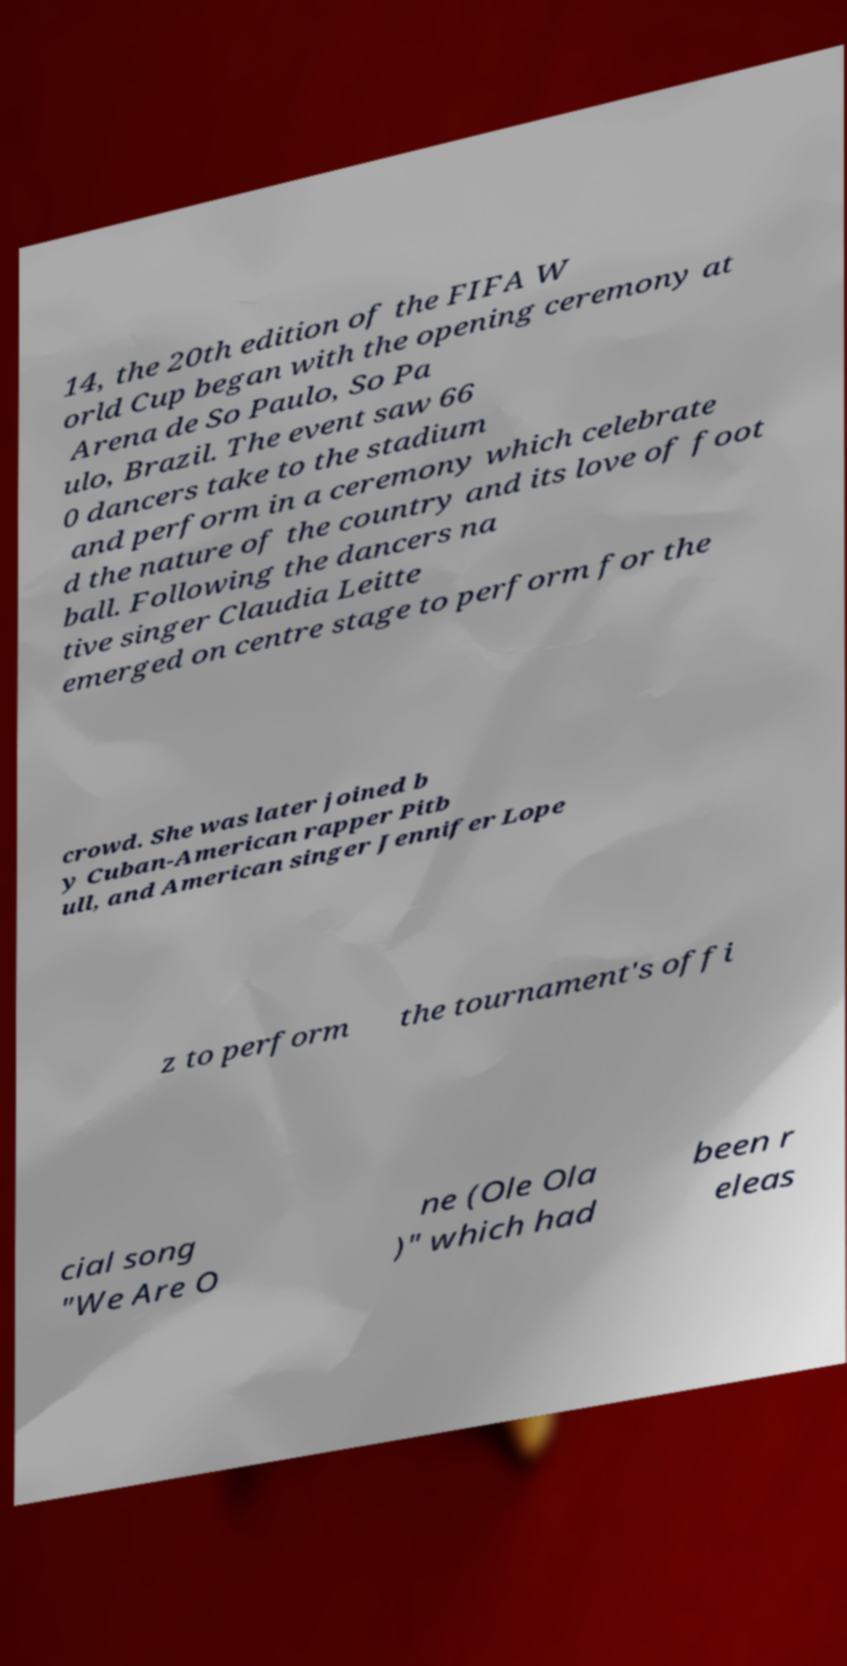Could you assist in decoding the text presented in this image and type it out clearly? 14, the 20th edition of the FIFA W orld Cup began with the opening ceremony at Arena de So Paulo, So Pa ulo, Brazil. The event saw 66 0 dancers take to the stadium and perform in a ceremony which celebrate d the nature of the country and its love of foot ball. Following the dancers na tive singer Claudia Leitte emerged on centre stage to perform for the crowd. She was later joined b y Cuban-American rapper Pitb ull, and American singer Jennifer Lope z to perform the tournament's offi cial song "We Are O ne (Ole Ola )" which had been r eleas 